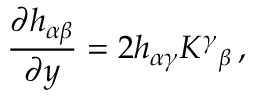<formula> <loc_0><loc_0><loc_500><loc_500>{ \frac { \partial h _ { \alpha \beta } } { \partial y } } = 2 h _ { \alpha \gamma } K ^ { \gamma _ { \beta } \, ,</formula> 